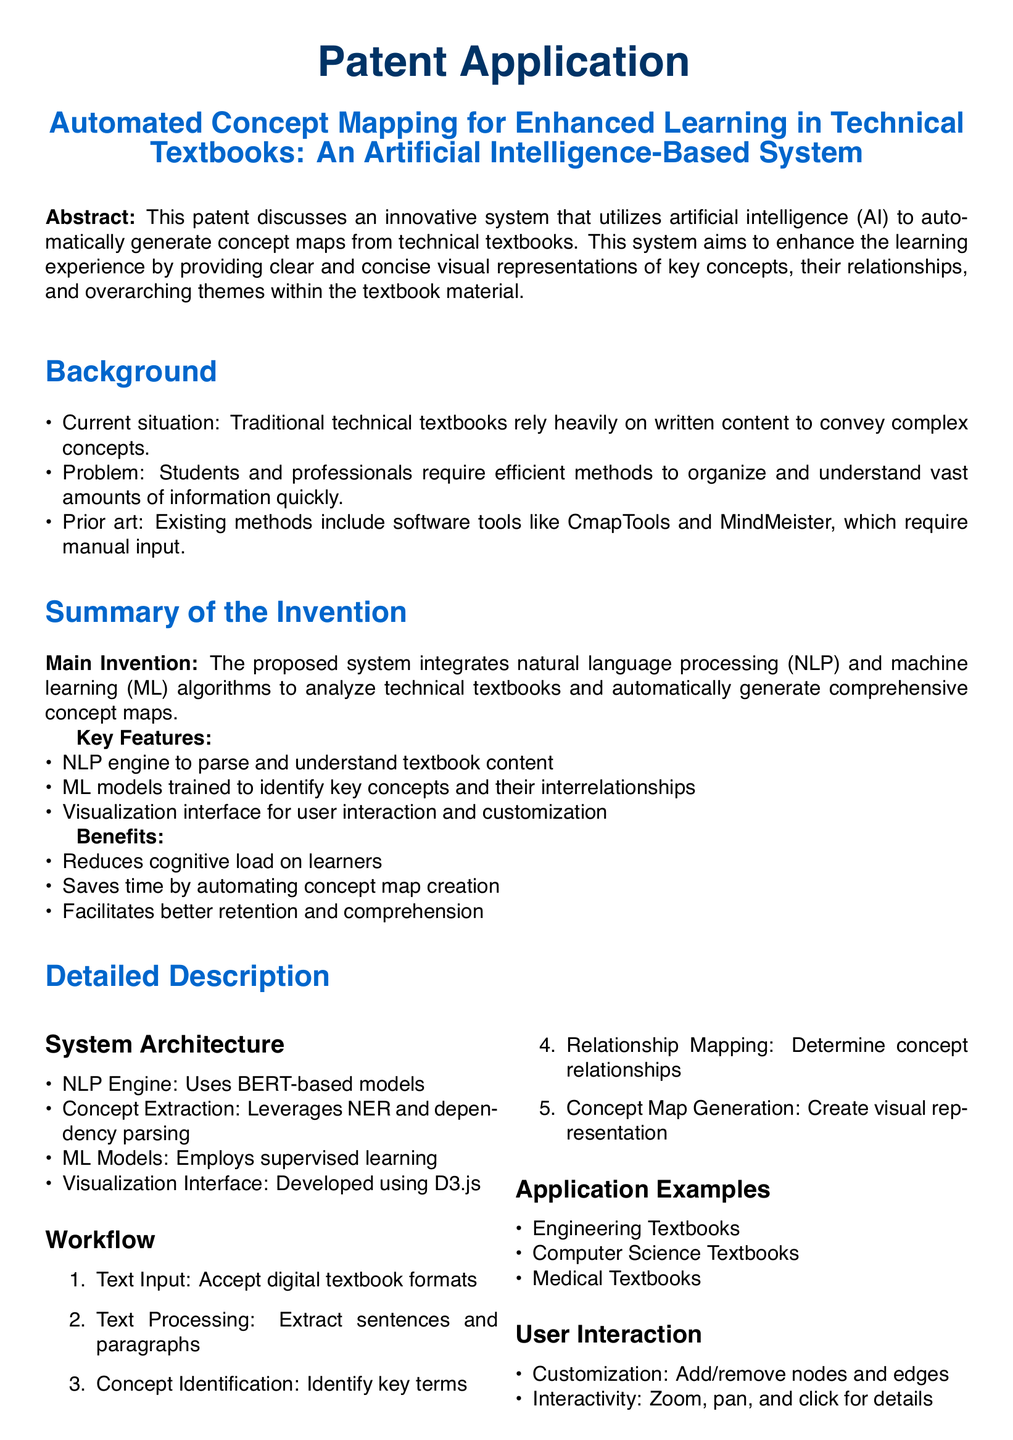What is the main invention of the application? The main invention is a system that integrates natural language processing and machine learning algorithms to analyze technical textbooks and automatically generate comprehensive concept maps.
Answer: A system that integrates natural language processing and machine learning algorithms What technology does the NLP engine use? The NLP engine uses BERT-based models to analyze textbook content.
Answer: BERT-based models What are the benefits of the proposed system? The benefits mentioned includes reducing cognitive load, saving time, and facilitating better retention and comprehension.
Answer: Reduces cognitive load on learners What types of textbooks can the system be applied to? The system can be applied to engineering, computer science, and medical textbooks.
Answer: Engineering, Computer Science, Medical How many steps are in the workflow? The workflow consists of five steps: text input, text processing, concept identification, relationship mapping, and concept map generation.
Answer: Five steps What is the purpose of the visualization interface? The visualization interface allows user interaction and customization of the concept maps generated by the system.
Answer: User interaction and customization Which techniques are leveraged for concept extraction? The techniques for concept extraction include named entity recognition and dependency parsing.
Answer: Named entity recognition and dependency parsing What does the automated system aim to enhance? The automated system aims to enhance the learning experience by providing visual representations of key concepts.
Answer: The learning experience What is the document type of this text? The document type of this text is a patent application.
Answer: Patent application 